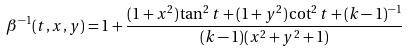<formula> <loc_0><loc_0><loc_500><loc_500>\beta ^ { - 1 } ( t , x , y ) = 1 + \frac { ( 1 + x ^ { 2 } ) \tan ^ { 2 } t + ( 1 + y ^ { 2 } ) \cot ^ { 2 } t + ( k - 1 ) ^ { - 1 } } { ( k - 1 ) ( x ^ { 2 } + y ^ { 2 } + 1 ) }</formula> 